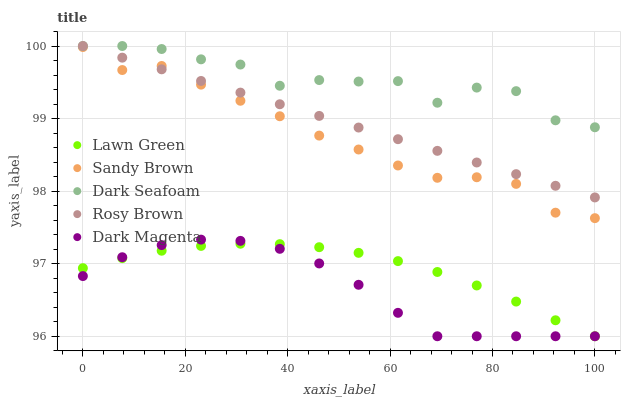Does Dark Magenta have the minimum area under the curve?
Answer yes or no. Yes. Does Dark Seafoam have the maximum area under the curve?
Answer yes or no. Yes. Does Rosy Brown have the minimum area under the curve?
Answer yes or no. No. Does Rosy Brown have the maximum area under the curve?
Answer yes or no. No. Is Rosy Brown the smoothest?
Answer yes or no. Yes. Is Dark Seafoam the roughest?
Answer yes or no. Yes. Is Dark Seafoam the smoothest?
Answer yes or no. No. Is Rosy Brown the roughest?
Answer yes or no. No. Does Lawn Green have the lowest value?
Answer yes or no. Yes. Does Rosy Brown have the lowest value?
Answer yes or no. No. Does Rosy Brown have the highest value?
Answer yes or no. Yes. Does Sandy Brown have the highest value?
Answer yes or no. No. Is Dark Magenta less than Dark Seafoam?
Answer yes or no. Yes. Is Sandy Brown greater than Dark Magenta?
Answer yes or no. Yes. Does Sandy Brown intersect Rosy Brown?
Answer yes or no. Yes. Is Sandy Brown less than Rosy Brown?
Answer yes or no. No. Is Sandy Brown greater than Rosy Brown?
Answer yes or no. No. Does Dark Magenta intersect Dark Seafoam?
Answer yes or no. No. 